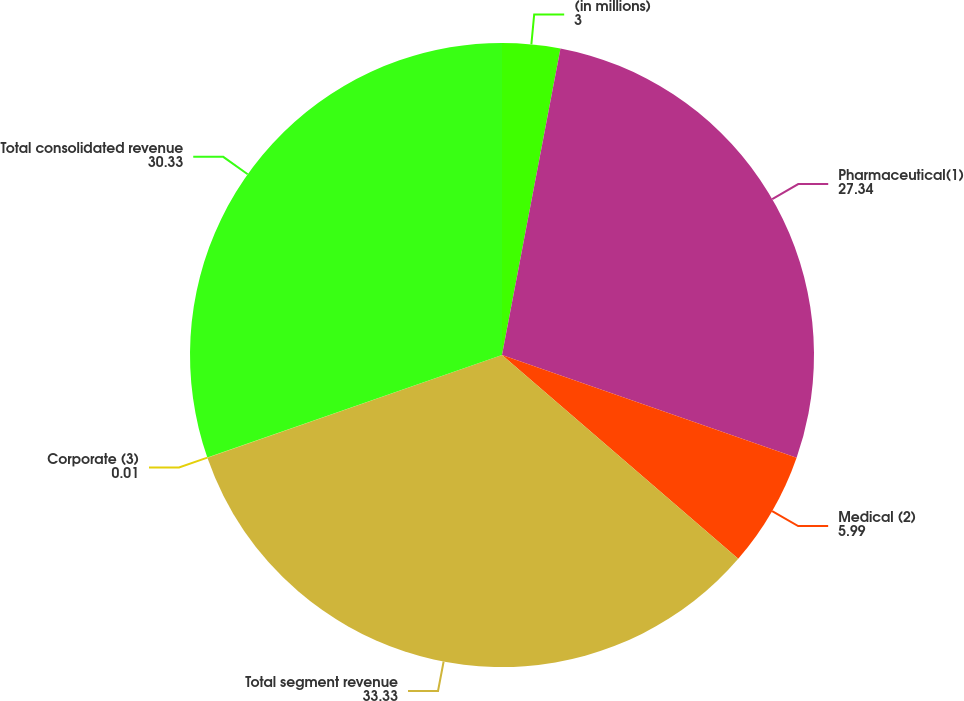<chart> <loc_0><loc_0><loc_500><loc_500><pie_chart><fcel>(in millions)<fcel>Pharmaceutical(1)<fcel>Medical (2)<fcel>Total segment revenue<fcel>Corporate (3)<fcel>Total consolidated revenue<nl><fcel>3.0%<fcel>27.34%<fcel>5.99%<fcel>33.33%<fcel>0.01%<fcel>30.33%<nl></chart> 